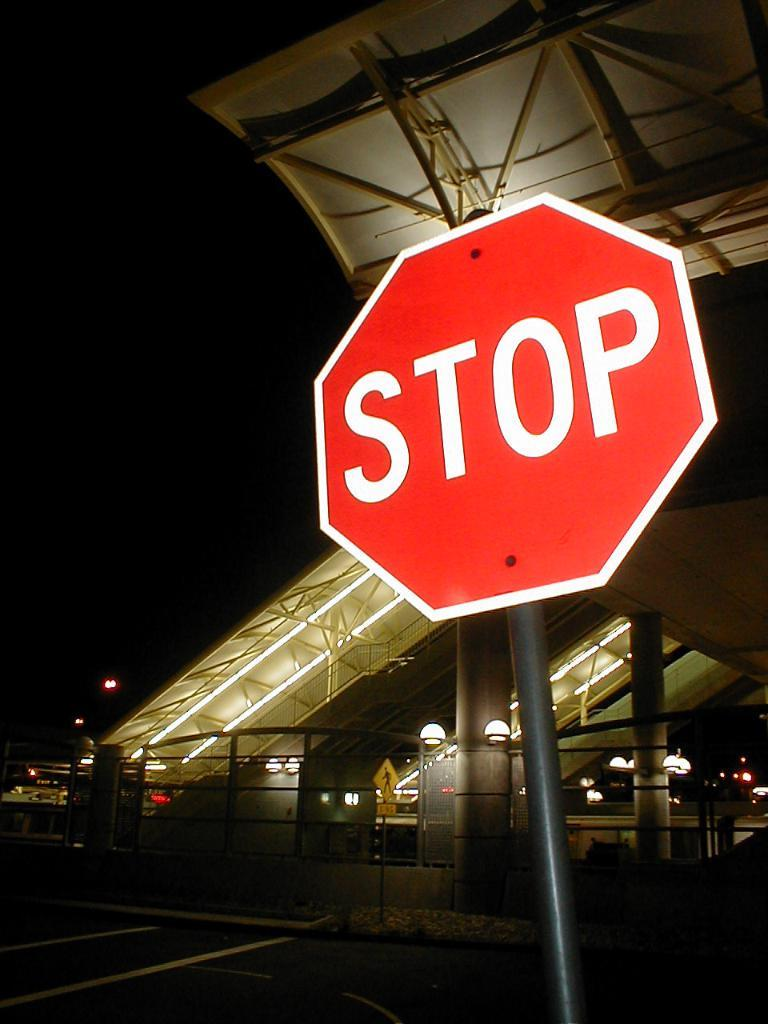<image>
Present a compact description of the photo's key features. The red stop sign has the words stop on it 